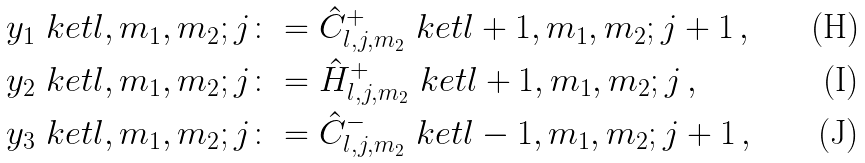Convert formula to latex. <formula><loc_0><loc_0><loc_500><loc_500>y _ { 1 } \ k e t { l , m _ { 1 } , m _ { 2 } ; j } & \colon = \hat { C } ^ { + } _ { l , j , m _ { 2 } } \ k e t { l + 1 , m _ { 1 } , m _ { 2 } ; j + 1 } \, , \\ y _ { 2 } \ k e t { l , m _ { 1 } , m _ { 2 } ; j } & \colon = \hat { H } ^ { + } _ { l , j , m _ { 2 } } \ k e t { l + 1 , m _ { 1 } , m _ { 2 } ; j } \, , \\ y _ { 3 } \ k e t { l , m _ { 1 } , m _ { 2 } ; j } & \colon = \hat { C } ^ { - } _ { l , j , m _ { 2 } } \ k e t { l - 1 , m _ { 1 } , m _ { 2 } ; j + 1 } \, ,</formula> 